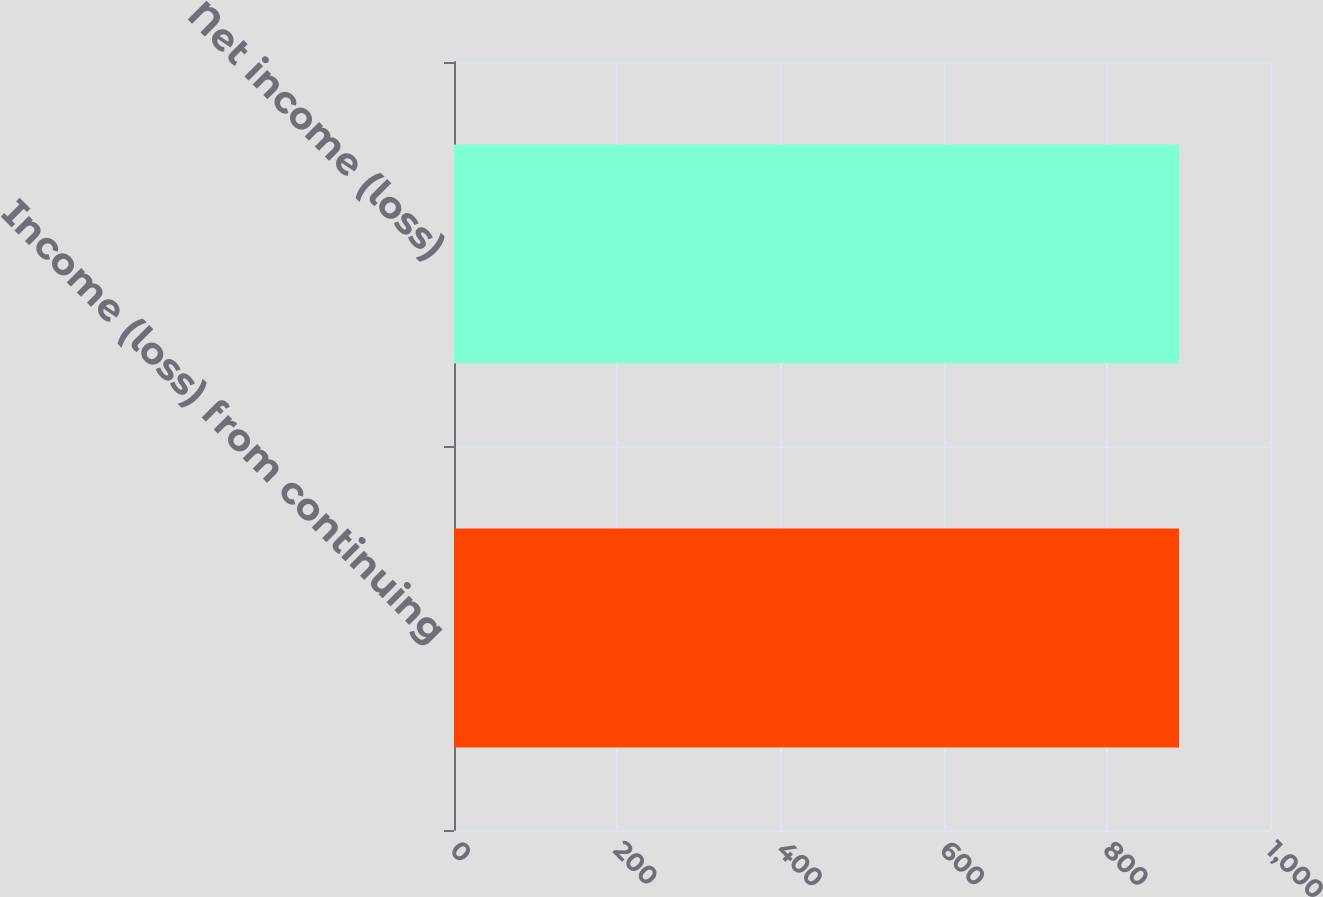<chart> <loc_0><loc_0><loc_500><loc_500><bar_chart><fcel>Income (loss) from continuing<fcel>Net income (loss)<nl><fcel>888.6<fcel>888.7<nl></chart> 